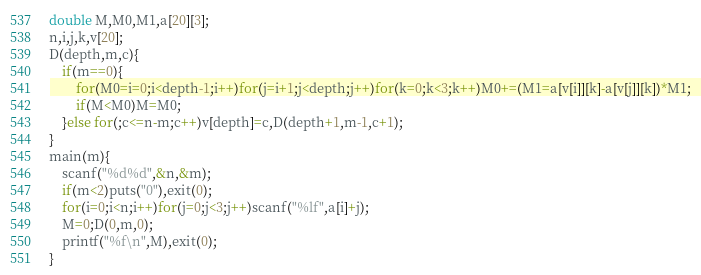<code> <loc_0><loc_0><loc_500><loc_500><_C_>double M,M0,M1,a[20][3];
n,i,j,k,v[20];
D(depth,m,c){
	if(m==0){
		for(M0=i=0;i<depth-1;i++)for(j=i+1;j<depth;j++)for(k=0;k<3;k++)M0+=(M1=a[v[i]][k]-a[v[j]][k])*M1;
		if(M<M0)M=M0;
	}else for(;c<=n-m;c++)v[depth]=c,D(depth+1,m-1,c+1);
}
main(m){
	scanf("%d%d",&n,&m);
	if(m<2)puts("0"),exit(0);
	for(i=0;i<n;i++)for(j=0;j<3;j++)scanf("%lf",a[i]+j);
	M=0;D(0,m,0);
	printf("%f\n",M),exit(0);
}</code> 